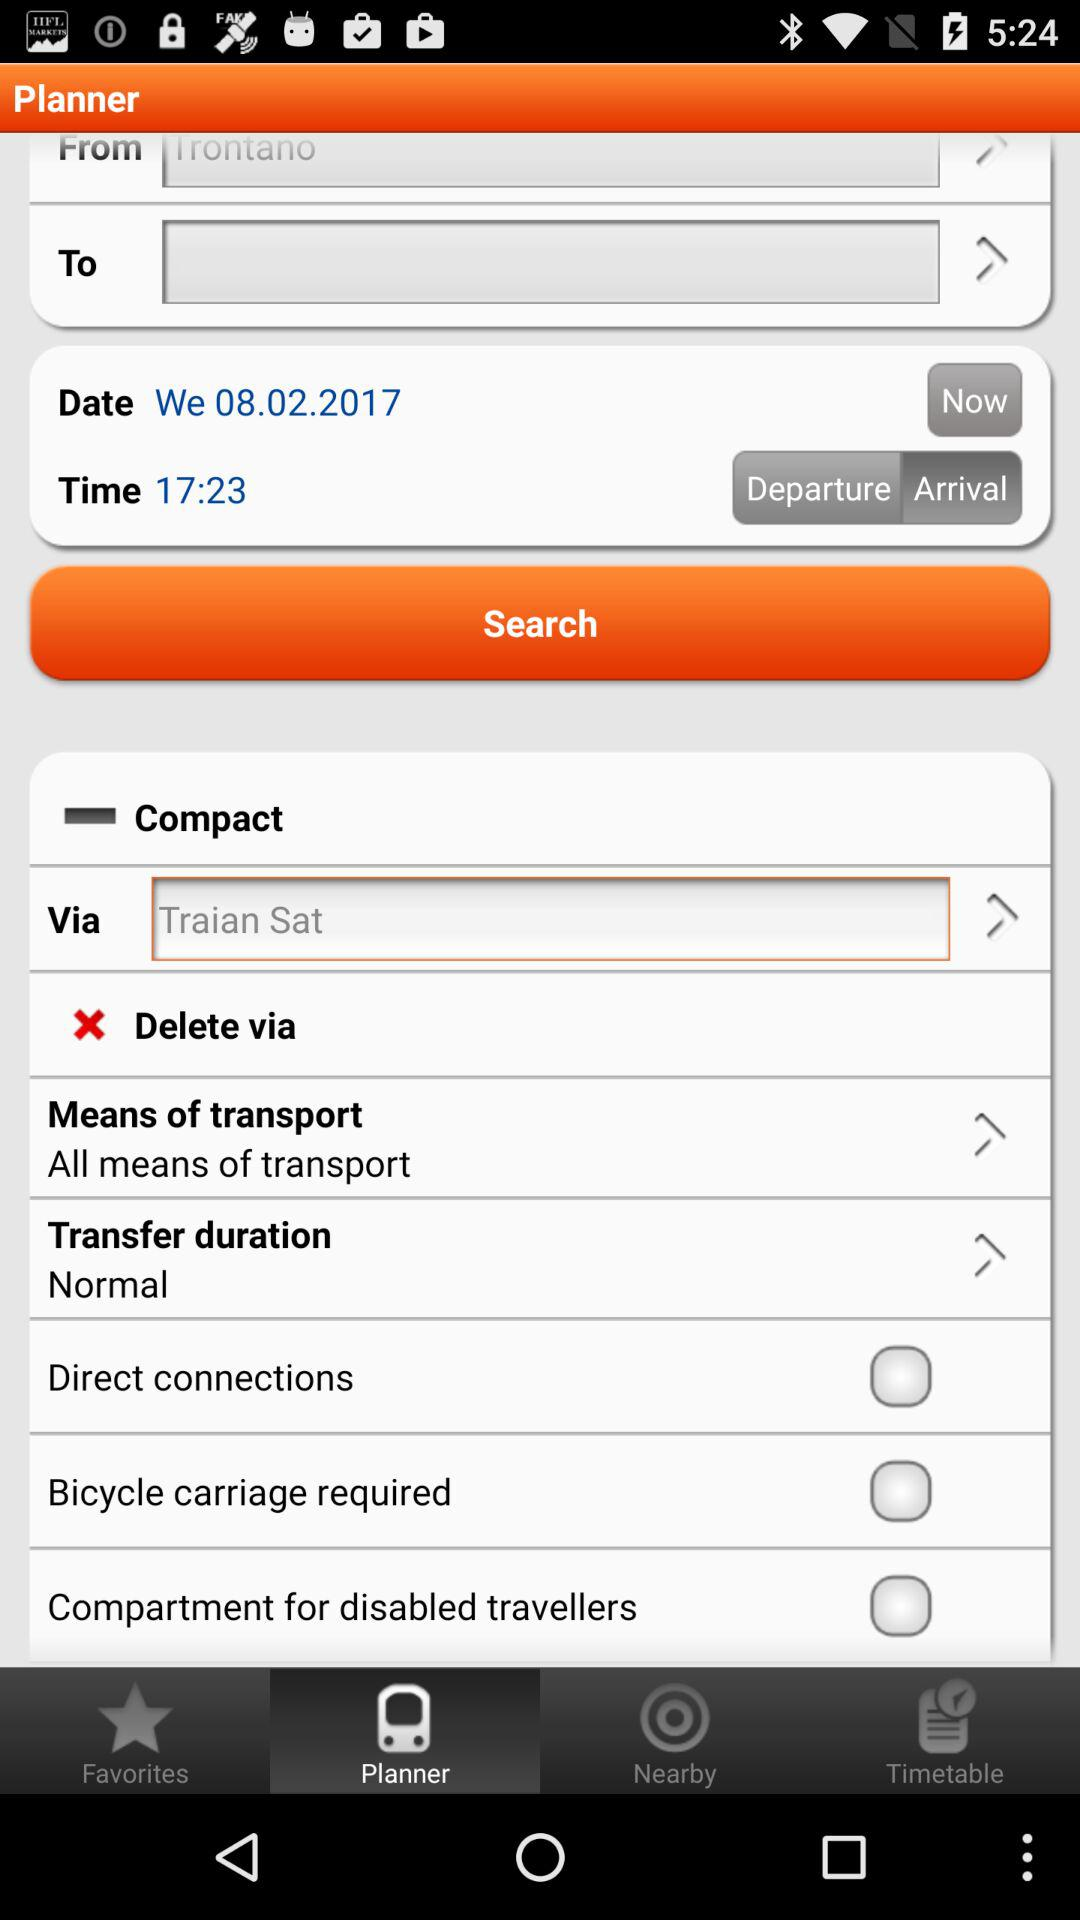Is the "Direct connections" checked or not? "Direct connections" is not checked. 